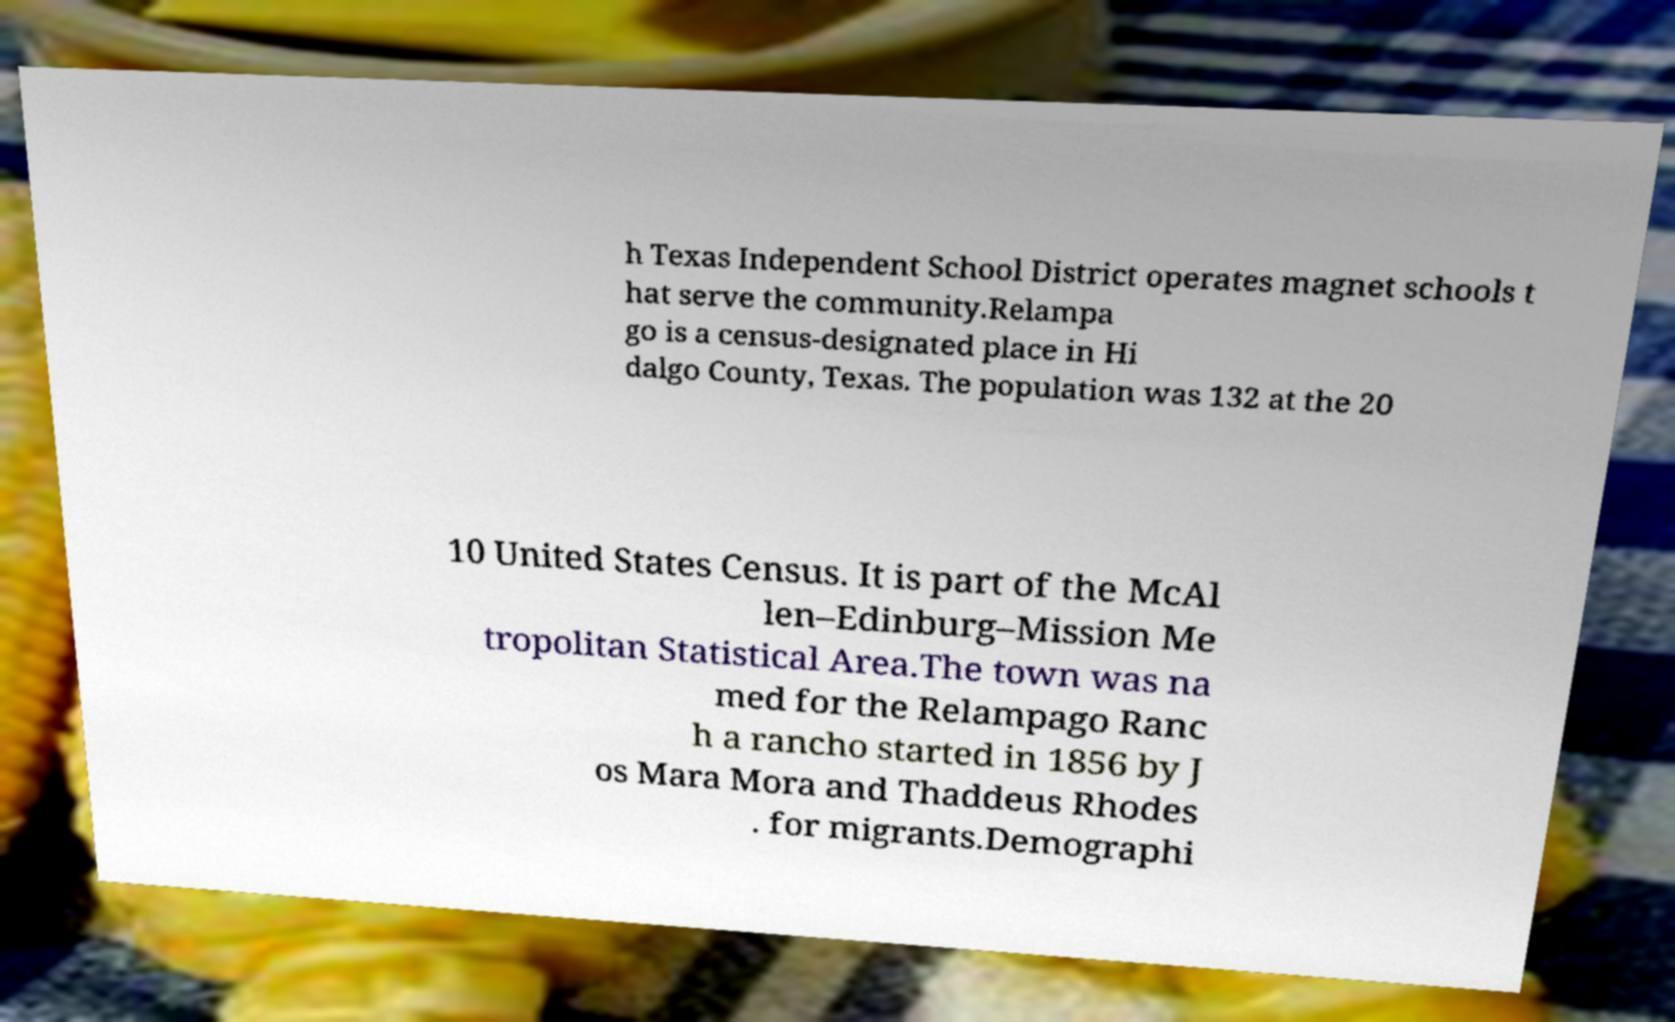What messages or text are displayed in this image? I need them in a readable, typed format. h Texas Independent School District operates magnet schools t hat serve the community.Relampa go is a census-designated place in Hi dalgo County, Texas. The population was 132 at the 20 10 United States Census. It is part of the McAl len–Edinburg–Mission Me tropolitan Statistical Area.The town was na med for the Relampago Ranc h a rancho started in 1856 by J os Mara Mora and Thaddeus Rhodes . for migrants.Demographi 